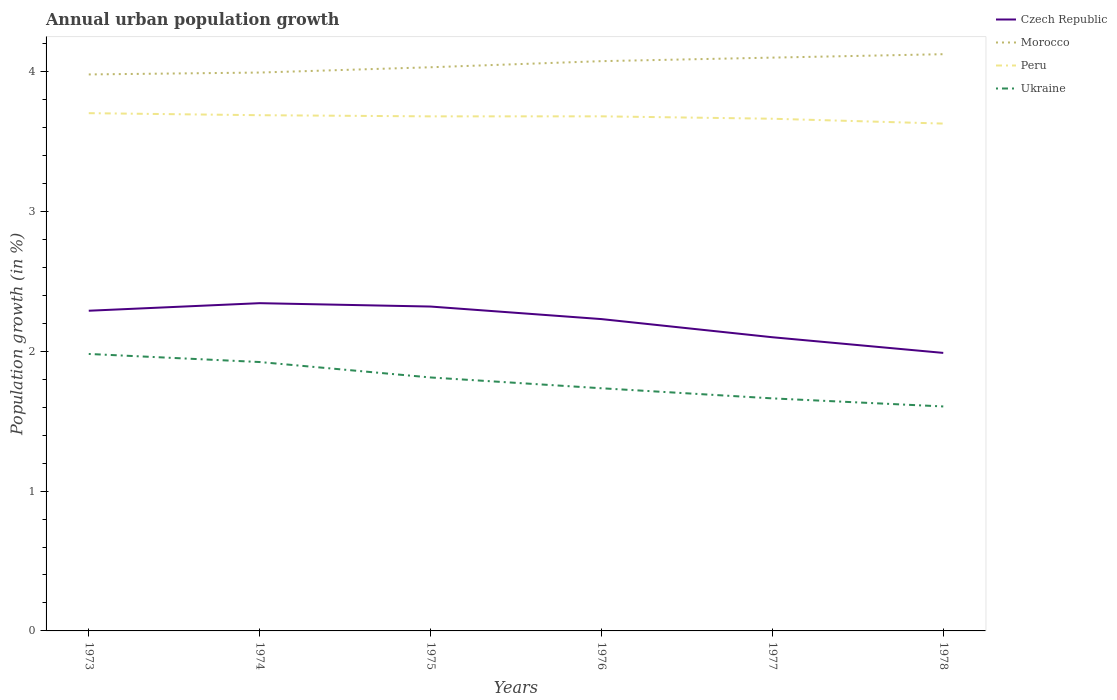How many different coloured lines are there?
Your answer should be very brief. 4. Is the number of lines equal to the number of legend labels?
Provide a short and direct response. Yes. Across all years, what is the maximum percentage of urban population growth in Morocco?
Provide a succinct answer. 3.98. In which year was the percentage of urban population growth in Ukraine maximum?
Offer a terse response. 1978. What is the total percentage of urban population growth in Morocco in the graph?
Provide a short and direct response. -0.04. What is the difference between the highest and the second highest percentage of urban population growth in Czech Republic?
Your response must be concise. 0.36. What is the difference between the highest and the lowest percentage of urban population growth in Peru?
Provide a short and direct response. 4. How many lines are there?
Offer a very short reply. 4. Are the values on the major ticks of Y-axis written in scientific E-notation?
Your response must be concise. No. Does the graph contain any zero values?
Provide a short and direct response. No. Does the graph contain grids?
Your answer should be compact. No. Where does the legend appear in the graph?
Make the answer very short. Top right. How are the legend labels stacked?
Your answer should be compact. Vertical. What is the title of the graph?
Offer a terse response. Annual urban population growth. What is the label or title of the X-axis?
Provide a short and direct response. Years. What is the label or title of the Y-axis?
Provide a short and direct response. Population growth (in %). What is the Population growth (in %) of Czech Republic in 1973?
Keep it short and to the point. 2.29. What is the Population growth (in %) in Morocco in 1973?
Offer a terse response. 3.98. What is the Population growth (in %) in Peru in 1973?
Give a very brief answer. 3.7. What is the Population growth (in %) in Ukraine in 1973?
Your answer should be compact. 1.98. What is the Population growth (in %) in Czech Republic in 1974?
Give a very brief answer. 2.34. What is the Population growth (in %) in Morocco in 1974?
Make the answer very short. 3.99. What is the Population growth (in %) in Peru in 1974?
Your answer should be compact. 3.69. What is the Population growth (in %) in Ukraine in 1974?
Your answer should be compact. 1.92. What is the Population growth (in %) in Czech Republic in 1975?
Provide a short and direct response. 2.32. What is the Population growth (in %) of Morocco in 1975?
Offer a very short reply. 4.03. What is the Population growth (in %) of Peru in 1975?
Your response must be concise. 3.68. What is the Population growth (in %) in Ukraine in 1975?
Provide a short and direct response. 1.81. What is the Population growth (in %) of Czech Republic in 1976?
Make the answer very short. 2.23. What is the Population growth (in %) in Morocco in 1976?
Provide a short and direct response. 4.07. What is the Population growth (in %) of Peru in 1976?
Offer a very short reply. 3.68. What is the Population growth (in %) in Ukraine in 1976?
Your answer should be compact. 1.73. What is the Population growth (in %) in Czech Republic in 1977?
Your answer should be compact. 2.1. What is the Population growth (in %) in Morocco in 1977?
Keep it short and to the point. 4.1. What is the Population growth (in %) of Peru in 1977?
Make the answer very short. 3.66. What is the Population growth (in %) in Ukraine in 1977?
Make the answer very short. 1.66. What is the Population growth (in %) of Czech Republic in 1978?
Provide a succinct answer. 1.99. What is the Population growth (in %) of Morocco in 1978?
Your answer should be very brief. 4.12. What is the Population growth (in %) in Peru in 1978?
Ensure brevity in your answer.  3.63. What is the Population growth (in %) in Ukraine in 1978?
Provide a short and direct response. 1.6. Across all years, what is the maximum Population growth (in %) of Czech Republic?
Offer a terse response. 2.34. Across all years, what is the maximum Population growth (in %) in Morocco?
Provide a short and direct response. 4.12. Across all years, what is the maximum Population growth (in %) of Peru?
Make the answer very short. 3.7. Across all years, what is the maximum Population growth (in %) in Ukraine?
Offer a very short reply. 1.98. Across all years, what is the minimum Population growth (in %) in Czech Republic?
Make the answer very short. 1.99. Across all years, what is the minimum Population growth (in %) in Morocco?
Your answer should be compact. 3.98. Across all years, what is the minimum Population growth (in %) of Peru?
Your answer should be very brief. 3.63. Across all years, what is the minimum Population growth (in %) in Ukraine?
Provide a short and direct response. 1.6. What is the total Population growth (in %) in Czech Republic in the graph?
Provide a short and direct response. 13.27. What is the total Population growth (in %) of Morocco in the graph?
Make the answer very short. 24.3. What is the total Population growth (in %) in Peru in the graph?
Offer a terse response. 22.04. What is the total Population growth (in %) of Ukraine in the graph?
Keep it short and to the point. 10.72. What is the difference between the Population growth (in %) in Czech Republic in 1973 and that in 1974?
Ensure brevity in your answer.  -0.05. What is the difference between the Population growth (in %) in Morocco in 1973 and that in 1974?
Ensure brevity in your answer.  -0.01. What is the difference between the Population growth (in %) of Peru in 1973 and that in 1974?
Give a very brief answer. 0.01. What is the difference between the Population growth (in %) in Ukraine in 1973 and that in 1974?
Make the answer very short. 0.06. What is the difference between the Population growth (in %) in Czech Republic in 1973 and that in 1975?
Ensure brevity in your answer.  -0.03. What is the difference between the Population growth (in %) in Morocco in 1973 and that in 1975?
Keep it short and to the point. -0.05. What is the difference between the Population growth (in %) of Peru in 1973 and that in 1975?
Make the answer very short. 0.02. What is the difference between the Population growth (in %) of Ukraine in 1973 and that in 1975?
Your answer should be compact. 0.17. What is the difference between the Population growth (in %) of Czech Republic in 1973 and that in 1976?
Provide a succinct answer. 0.06. What is the difference between the Population growth (in %) of Morocco in 1973 and that in 1976?
Give a very brief answer. -0.09. What is the difference between the Population growth (in %) in Peru in 1973 and that in 1976?
Provide a succinct answer. 0.02. What is the difference between the Population growth (in %) of Ukraine in 1973 and that in 1976?
Give a very brief answer. 0.25. What is the difference between the Population growth (in %) of Czech Republic in 1973 and that in 1977?
Your answer should be compact. 0.19. What is the difference between the Population growth (in %) of Morocco in 1973 and that in 1977?
Offer a terse response. -0.12. What is the difference between the Population growth (in %) of Peru in 1973 and that in 1977?
Make the answer very short. 0.04. What is the difference between the Population growth (in %) in Ukraine in 1973 and that in 1977?
Provide a short and direct response. 0.32. What is the difference between the Population growth (in %) in Czech Republic in 1973 and that in 1978?
Keep it short and to the point. 0.3. What is the difference between the Population growth (in %) in Morocco in 1973 and that in 1978?
Provide a short and direct response. -0.14. What is the difference between the Population growth (in %) of Peru in 1973 and that in 1978?
Provide a short and direct response. 0.07. What is the difference between the Population growth (in %) of Ukraine in 1973 and that in 1978?
Your response must be concise. 0.38. What is the difference between the Population growth (in %) of Czech Republic in 1974 and that in 1975?
Your answer should be compact. 0.02. What is the difference between the Population growth (in %) of Morocco in 1974 and that in 1975?
Your answer should be very brief. -0.04. What is the difference between the Population growth (in %) of Peru in 1974 and that in 1975?
Your answer should be very brief. 0.01. What is the difference between the Population growth (in %) in Ukraine in 1974 and that in 1975?
Provide a succinct answer. 0.11. What is the difference between the Population growth (in %) in Czech Republic in 1974 and that in 1976?
Provide a short and direct response. 0.11. What is the difference between the Population growth (in %) of Morocco in 1974 and that in 1976?
Your response must be concise. -0.08. What is the difference between the Population growth (in %) in Peru in 1974 and that in 1976?
Make the answer very short. 0.01. What is the difference between the Population growth (in %) of Ukraine in 1974 and that in 1976?
Your answer should be compact. 0.19. What is the difference between the Population growth (in %) in Czech Republic in 1974 and that in 1977?
Give a very brief answer. 0.24. What is the difference between the Population growth (in %) of Morocco in 1974 and that in 1977?
Offer a terse response. -0.11. What is the difference between the Population growth (in %) in Peru in 1974 and that in 1977?
Provide a succinct answer. 0.03. What is the difference between the Population growth (in %) of Ukraine in 1974 and that in 1977?
Offer a very short reply. 0.26. What is the difference between the Population growth (in %) in Czech Republic in 1974 and that in 1978?
Keep it short and to the point. 0.36. What is the difference between the Population growth (in %) in Morocco in 1974 and that in 1978?
Provide a short and direct response. -0.13. What is the difference between the Population growth (in %) of Peru in 1974 and that in 1978?
Provide a short and direct response. 0.06. What is the difference between the Population growth (in %) of Ukraine in 1974 and that in 1978?
Ensure brevity in your answer.  0.32. What is the difference between the Population growth (in %) in Czech Republic in 1975 and that in 1976?
Your answer should be compact. 0.09. What is the difference between the Population growth (in %) in Morocco in 1975 and that in 1976?
Provide a short and direct response. -0.04. What is the difference between the Population growth (in %) in Peru in 1975 and that in 1976?
Keep it short and to the point. -0. What is the difference between the Population growth (in %) of Ukraine in 1975 and that in 1976?
Provide a short and direct response. 0.08. What is the difference between the Population growth (in %) of Czech Republic in 1975 and that in 1977?
Offer a very short reply. 0.22. What is the difference between the Population growth (in %) of Morocco in 1975 and that in 1977?
Offer a very short reply. -0.07. What is the difference between the Population growth (in %) in Peru in 1975 and that in 1977?
Your answer should be very brief. 0.02. What is the difference between the Population growth (in %) in Ukraine in 1975 and that in 1977?
Keep it short and to the point. 0.15. What is the difference between the Population growth (in %) of Czech Republic in 1975 and that in 1978?
Provide a succinct answer. 0.33. What is the difference between the Population growth (in %) in Morocco in 1975 and that in 1978?
Offer a very short reply. -0.09. What is the difference between the Population growth (in %) in Peru in 1975 and that in 1978?
Your answer should be compact. 0.05. What is the difference between the Population growth (in %) in Ukraine in 1975 and that in 1978?
Your answer should be compact. 0.21. What is the difference between the Population growth (in %) of Czech Republic in 1976 and that in 1977?
Your answer should be very brief. 0.13. What is the difference between the Population growth (in %) in Morocco in 1976 and that in 1977?
Give a very brief answer. -0.03. What is the difference between the Population growth (in %) in Peru in 1976 and that in 1977?
Offer a very short reply. 0.02. What is the difference between the Population growth (in %) of Ukraine in 1976 and that in 1977?
Your answer should be compact. 0.07. What is the difference between the Population growth (in %) of Czech Republic in 1976 and that in 1978?
Make the answer very short. 0.24. What is the difference between the Population growth (in %) of Morocco in 1976 and that in 1978?
Offer a terse response. -0.05. What is the difference between the Population growth (in %) in Peru in 1976 and that in 1978?
Provide a short and direct response. 0.05. What is the difference between the Population growth (in %) of Ukraine in 1976 and that in 1978?
Make the answer very short. 0.13. What is the difference between the Population growth (in %) in Czech Republic in 1977 and that in 1978?
Offer a terse response. 0.11. What is the difference between the Population growth (in %) in Morocco in 1977 and that in 1978?
Your answer should be compact. -0.02. What is the difference between the Population growth (in %) in Peru in 1977 and that in 1978?
Provide a succinct answer. 0.03. What is the difference between the Population growth (in %) in Ukraine in 1977 and that in 1978?
Ensure brevity in your answer.  0.06. What is the difference between the Population growth (in %) of Czech Republic in 1973 and the Population growth (in %) of Morocco in 1974?
Your answer should be compact. -1.7. What is the difference between the Population growth (in %) of Czech Republic in 1973 and the Population growth (in %) of Peru in 1974?
Give a very brief answer. -1.4. What is the difference between the Population growth (in %) in Czech Republic in 1973 and the Population growth (in %) in Ukraine in 1974?
Your response must be concise. 0.37. What is the difference between the Population growth (in %) of Morocco in 1973 and the Population growth (in %) of Peru in 1974?
Your response must be concise. 0.29. What is the difference between the Population growth (in %) of Morocco in 1973 and the Population growth (in %) of Ukraine in 1974?
Your answer should be compact. 2.06. What is the difference between the Population growth (in %) in Peru in 1973 and the Population growth (in %) in Ukraine in 1974?
Your response must be concise. 1.78. What is the difference between the Population growth (in %) of Czech Republic in 1973 and the Population growth (in %) of Morocco in 1975?
Offer a very short reply. -1.74. What is the difference between the Population growth (in %) in Czech Republic in 1973 and the Population growth (in %) in Peru in 1975?
Provide a succinct answer. -1.39. What is the difference between the Population growth (in %) of Czech Republic in 1973 and the Population growth (in %) of Ukraine in 1975?
Keep it short and to the point. 0.48. What is the difference between the Population growth (in %) in Morocco in 1973 and the Population growth (in %) in Peru in 1975?
Provide a short and direct response. 0.3. What is the difference between the Population growth (in %) of Morocco in 1973 and the Population growth (in %) of Ukraine in 1975?
Offer a terse response. 2.17. What is the difference between the Population growth (in %) in Peru in 1973 and the Population growth (in %) in Ukraine in 1975?
Offer a terse response. 1.89. What is the difference between the Population growth (in %) of Czech Republic in 1973 and the Population growth (in %) of Morocco in 1976?
Make the answer very short. -1.78. What is the difference between the Population growth (in %) in Czech Republic in 1973 and the Population growth (in %) in Peru in 1976?
Keep it short and to the point. -1.39. What is the difference between the Population growth (in %) of Czech Republic in 1973 and the Population growth (in %) of Ukraine in 1976?
Offer a terse response. 0.55. What is the difference between the Population growth (in %) of Morocco in 1973 and the Population growth (in %) of Peru in 1976?
Offer a terse response. 0.3. What is the difference between the Population growth (in %) of Morocco in 1973 and the Population growth (in %) of Ukraine in 1976?
Offer a very short reply. 2.24. What is the difference between the Population growth (in %) in Peru in 1973 and the Population growth (in %) in Ukraine in 1976?
Provide a succinct answer. 1.97. What is the difference between the Population growth (in %) in Czech Republic in 1973 and the Population growth (in %) in Morocco in 1977?
Offer a very short reply. -1.81. What is the difference between the Population growth (in %) in Czech Republic in 1973 and the Population growth (in %) in Peru in 1977?
Provide a short and direct response. -1.37. What is the difference between the Population growth (in %) in Czech Republic in 1973 and the Population growth (in %) in Ukraine in 1977?
Ensure brevity in your answer.  0.63. What is the difference between the Population growth (in %) in Morocco in 1973 and the Population growth (in %) in Peru in 1977?
Provide a short and direct response. 0.32. What is the difference between the Population growth (in %) in Morocco in 1973 and the Population growth (in %) in Ukraine in 1977?
Ensure brevity in your answer.  2.32. What is the difference between the Population growth (in %) of Peru in 1973 and the Population growth (in %) of Ukraine in 1977?
Provide a short and direct response. 2.04. What is the difference between the Population growth (in %) in Czech Republic in 1973 and the Population growth (in %) in Morocco in 1978?
Ensure brevity in your answer.  -1.83. What is the difference between the Population growth (in %) of Czech Republic in 1973 and the Population growth (in %) of Peru in 1978?
Provide a short and direct response. -1.34. What is the difference between the Population growth (in %) in Czech Republic in 1973 and the Population growth (in %) in Ukraine in 1978?
Keep it short and to the point. 0.68. What is the difference between the Population growth (in %) of Morocco in 1973 and the Population growth (in %) of Peru in 1978?
Offer a very short reply. 0.35. What is the difference between the Population growth (in %) in Morocco in 1973 and the Population growth (in %) in Ukraine in 1978?
Give a very brief answer. 2.37. What is the difference between the Population growth (in %) of Peru in 1973 and the Population growth (in %) of Ukraine in 1978?
Give a very brief answer. 2.1. What is the difference between the Population growth (in %) in Czech Republic in 1974 and the Population growth (in %) in Morocco in 1975?
Offer a very short reply. -1.69. What is the difference between the Population growth (in %) of Czech Republic in 1974 and the Population growth (in %) of Peru in 1975?
Offer a terse response. -1.34. What is the difference between the Population growth (in %) in Czech Republic in 1974 and the Population growth (in %) in Ukraine in 1975?
Give a very brief answer. 0.53. What is the difference between the Population growth (in %) of Morocco in 1974 and the Population growth (in %) of Peru in 1975?
Your answer should be very brief. 0.31. What is the difference between the Population growth (in %) of Morocco in 1974 and the Population growth (in %) of Ukraine in 1975?
Provide a succinct answer. 2.18. What is the difference between the Population growth (in %) in Peru in 1974 and the Population growth (in %) in Ukraine in 1975?
Provide a succinct answer. 1.88. What is the difference between the Population growth (in %) in Czech Republic in 1974 and the Population growth (in %) in Morocco in 1976?
Your answer should be compact. -1.73. What is the difference between the Population growth (in %) of Czech Republic in 1974 and the Population growth (in %) of Peru in 1976?
Your answer should be very brief. -1.34. What is the difference between the Population growth (in %) in Czech Republic in 1974 and the Population growth (in %) in Ukraine in 1976?
Offer a terse response. 0.61. What is the difference between the Population growth (in %) of Morocco in 1974 and the Population growth (in %) of Peru in 1976?
Offer a very short reply. 0.31. What is the difference between the Population growth (in %) of Morocco in 1974 and the Population growth (in %) of Ukraine in 1976?
Your answer should be compact. 2.26. What is the difference between the Population growth (in %) in Peru in 1974 and the Population growth (in %) in Ukraine in 1976?
Offer a terse response. 1.95. What is the difference between the Population growth (in %) of Czech Republic in 1974 and the Population growth (in %) of Morocco in 1977?
Ensure brevity in your answer.  -1.76. What is the difference between the Population growth (in %) of Czech Republic in 1974 and the Population growth (in %) of Peru in 1977?
Give a very brief answer. -1.32. What is the difference between the Population growth (in %) of Czech Republic in 1974 and the Population growth (in %) of Ukraine in 1977?
Offer a terse response. 0.68. What is the difference between the Population growth (in %) in Morocco in 1974 and the Population growth (in %) in Peru in 1977?
Provide a short and direct response. 0.33. What is the difference between the Population growth (in %) in Morocco in 1974 and the Population growth (in %) in Ukraine in 1977?
Your answer should be very brief. 2.33. What is the difference between the Population growth (in %) of Peru in 1974 and the Population growth (in %) of Ukraine in 1977?
Make the answer very short. 2.02. What is the difference between the Population growth (in %) of Czech Republic in 1974 and the Population growth (in %) of Morocco in 1978?
Give a very brief answer. -1.78. What is the difference between the Population growth (in %) of Czech Republic in 1974 and the Population growth (in %) of Peru in 1978?
Provide a succinct answer. -1.28. What is the difference between the Population growth (in %) in Czech Republic in 1974 and the Population growth (in %) in Ukraine in 1978?
Make the answer very short. 0.74. What is the difference between the Population growth (in %) of Morocco in 1974 and the Population growth (in %) of Peru in 1978?
Your answer should be compact. 0.36. What is the difference between the Population growth (in %) of Morocco in 1974 and the Population growth (in %) of Ukraine in 1978?
Offer a terse response. 2.39. What is the difference between the Population growth (in %) in Peru in 1974 and the Population growth (in %) in Ukraine in 1978?
Provide a short and direct response. 2.08. What is the difference between the Population growth (in %) in Czech Republic in 1975 and the Population growth (in %) in Morocco in 1976?
Your response must be concise. -1.75. What is the difference between the Population growth (in %) of Czech Republic in 1975 and the Population growth (in %) of Peru in 1976?
Keep it short and to the point. -1.36. What is the difference between the Population growth (in %) of Czech Republic in 1975 and the Population growth (in %) of Ukraine in 1976?
Ensure brevity in your answer.  0.58. What is the difference between the Population growth (in %) of Morocco in 1975 and the Population growth (in %) of Peru in 1976?
Give a very brief answer. 0.35. What is the difference between the Population growth (in %) in Morocco in 1975 and the Population growth (in %) in Ukraine in 1976?
Your answer should be very brief. 2.3. What is the difference between the Population growth (in %) in Peru in 1975 and the Population growth (in %) in Ukraine in 1976?
Offer a very short reply. 1.94. What is the difference between the Population growth (in %) of Czech Republic in 1975 and the Population growth (in %) of Morocco in 1977?
Give a very brief answer. -1.78. What is the difference between the Population growth (in %) of Czech Republic in 1975 and the Population growth (in %) of Peru in 1977?
Your answer should be very brief. -1.34. What is the difference between the Population growth (in %) of Czech Republic in 1975 and the Population growth (in %) of Ukraine in 1977?
Your answer should be compact. 0.66. What is the difference between the Population growth (in %) in Morocco in 1975 and the Population growth (in %) in Peru in 1977?
Keep it short and to the point. 0.37. What is the difference between the Population growth (in %) of Morocco in 1975 and the Population growth (in %) of Ukraine in 1977?
Keep it short and to the point. 2.37. What is the difference between the Population growth (in %) of Peru in 1975 and the Population growth (in %) of Ukraine in 1977?
Your answer should be very brief. 2.02. What is the difference between the Population growth (in %) of Czech Republic in 1975 and the Population growth (in %) of Morocco in 1978?
Offer a very short reply. -1.8. What is the difference between the Population growth (in %) in Czech Republic in 1975 and the Population growth (in %) in Peru in 1978?
Your answer should be very brief. -1.31. What is the difference between the Population growth (in %) of Czech Republic in 1975 and the Population growth (in %) of Ukraine in 1978?
Your answer should be compact. 0.71. What is the difference between the Population growth (in %) in Morocco in 1975 and the Population growth (in %) in Peru in 1978?
Your answer should be very brief. 0.4. What is the difference between the Population growth (in %) in Morocco in 1975 and the Population growth (in %) in Ukraine in 1978?
Provide a succinct answer. 2.43. What is the difference between the Population growth (in %) of Peru in 1975 and the Population growth (in %) of Ukraine in 1978?
Give a very brief answer. 2.07. What is the difference between the Population growth (in %) of Czech Republic in 1976 and the Population growth (in %) of Morocco in 1977?
Your response must be concise. -1.87. What is the difference between the Population growth (in %) in Czech Republic in 1976 and the Population growth (in %) in Peru in 1977?
Keep it short and to the point. -1.43. What is the difference between the Population growth (in %) of Czech Republic in 1976 and the Population growth (in %) of Ukraine in 1977?
Offer a terse response. 0.57. What is the difference between the Population growth (in %) of Morocco in 1976 and the Population growth (in %) of Peru in 1977?
Ensure brevity in your answer.  0.41. What is the difference between the Population growth (in %) in Morocco in 1976 and the Population growth (in %) in Ukraine in 1977?
Make the answer very short. 2.41. What is the difference between the Population growth (in %) of Peru in 1976 and the Population growth (in %) of Ukraine in 1977?
Provide a succinct answer. 2.02. What is the difference between the Population growth (in %) of Czech Republic in 1976 and the Population growth (in %) of Morocco in 1978?
Ensure brevity in your answer.  -1.89. What is the difference between the Population growth (in %) of Czech Republic in 1976 and the Population growth (in %) of Peru in 1978?
Keep it short and to the point. -1.4. What is the difference between the Population growth (in %) in Czech Republic in 1976 and the Population growth (in %) in Ukraine in 1978?
Your answer should be compact. 0.62. What is the difference between the Population growth (in %) of Morocco in 1976 and the Population growth (in %) of Peru in 1978?
Offer a very short reply. 0.45. What is the difference between the Population growth (in %) of Morocco in 1976 and the Population growth (in %) of Ukraine in 1978?
Keep it short and to the point. 2.47. What is the difference between the Population growth (in %) in Peru in 1976 and the Population growth (in %) in Ukraine in 1978?
Keep it short and to the point. 2.07. What is the difference between the Population growth (in %) of Czech Republic in 1977 and the Population growth (in %) of Morocco in 1978?
Your response must be concise. -2.02. What is the difference between the Population growth (in %) in Czech Republic in 1977 and the Population growth (in %) in Peru in 1978?
Ensure brevity in your answer.  -1.53. What is the difference between the Population growth (in %) in Czech Republic in 1977 and the Population growth (in %) in Ukraine in 1978?
Keep it short and to the point. 0.49. What is the difference between the Population growth (in %) in Morocco in 1977 and the Population growth (in %) in Peru in 1978?
Your response must be concise. 0.47. What is the difference between the Population growth (in %) of Morocco in 1977 and the Population growth (in %) of Ukraine in 1978?
Keep it short and to the point. 2.49. What is the difference between the Population growth (in %) in Peru in 1977 and the Population growth (in %) in Ukraine in 1978?
Give a very brief answer. 2.06. What is the average Population growth (in %) in Czech Republic per year?
Ensure brevity in your answer.  2.21. What is the average Population growth (in %) of Morocco per year?
Your response must be concise. 4.05. What is the average Population growth (in %) of Peru per year?
Ensure brevity in your answer.  3.67. What is the average Population growth (in %) in Ukraine per year?
Your answer should be very brief. 1.79. In the year 1973, what is the difference between the Population growth (in %) in Czech Republic and Population growth (in %) in Morocco?
Your answer should be very brief. -1.69. In the year 1973, what is the difference between the Population growth (in %) in Czech Republic and Population growth (in %) in Peru?
Your answer should be compact. -1.41. In the year 1973, what is the difference between the Population growth (in %) in Czech Republic and Population growth (in %) in Ukraine?
Ensure brevity in your answer.  0.31. In the year 1973, what is the difference between the Population growth (in %) of Morocco and Population growth (in %) of Peru?
Offer a terse response. 0.28. In the year 1973, what is the difference between the Population growth (in %) of Morocco and Population growth (in %) of Ukraine?
Ensure brevity in your answer.  2. In the year 1973, what is the difference between the Population growth (in %) of Peru and Population growth (in %) of Ukraine?
Offer a very short reply. 1.72. In the year 1974, what is the difference between the Population growth (in %) in Czech Republic and Population growth (in %) in Morocco?
Provide a succinct answer. -1.65. In the year 1974, what is the difference between the Population growth (in %) of Czech Republic and Population growth (in %) of Peru?
Make the answer very short. -1.34. In the year 1974, what is the difference between the Population growth (in %) in Czech Republic and Population growth (in %) in Ukraine?
Ensure brevity in your answer.  0.42. In the year 1974, what is the difference between the Population growth (in %) in Morocco and Population growth (in %) in Peru?
Make the answer very short. 0.3. In the year 1974, what is the difference between the Population growth (in %) of Morocco and Population growth (in %) of Ukraine?
Your response must be concise. 2.07. In the year 1974, what is the difference between the Population growth (in %) of Peru and Population growth (in %) of Ukraine?
Give a very brief answer. 1.76. In the year 1975, what is the difference between the Population growth (in %) in Czech Republic and Population growth (in %) in Morocco?
Your answer should be compact. -1.71. In the year 1975, what is the difference between the Population growth (in %) in Czech Republic and Population growth (in %) in Peru?
Your response must be concise. -1.36. In the year 1975, what is the difference between the Population growth (in %) in Czech Republic and Population growth (in %) in Ukraine?
Offer a very short reply. 0.51. In the year 1975, what is the difference between the Population growth (in %) of Morocco and Population growth (in %) of Peru?
Give a very brief answer. 0.35. In the year 1975, what is the difference between the Population growth (in %) in Morocco and Population growth (in %) in Ukraine?
Ensure brevity in your answer.  2.22. In the year 1975, what is the difference between the Population growth (in %) in Peru and Population growth (in %) in Ukraine?
Offer a very short reply. 1.87. In the year 1976, what is the difference between the Population growth (in %) in Czech Republic and Population growth (in %) in Morocco?
Offer a terse response. -1.84. In the year 1976, what is the difference between the Population growth (in %) of Czech Republic and Population growth (in %) of Peru?
Ensure brevity in your answer.  -1.45. In the year 1976, what is the difference between the Population growth (in %) of Czech Republic and Population growth (in %) of Ukraine?
Provide a short and direct response. 0.49. In the year 1976, what is the difference between the Population growth (in %) in Morocco and Population growth (in %) in Peru?
Provide a succinct answer. 0.39. In the year 1976, what is the difference between the Population growth (in %) of Morocco and Population growth (in %) of Ukraine?
Offer a terse response. 2.34. In the year 1976, what is the difference between the Population growth (in %) in Peru and Population growth (in %) in Ukraine?
Offer a very short reply. 1.94. In the year 1977, what is the difference between the Population growth (in %) in Czech Republic and Population growth (in %) in Morocco?
Make the answer very short. -2. In the year 1977, what is the difference between the Population growth (in %) in Czech Republic and Population growth (in %) in Peru?
Your answer should be very brief. -1.56. In the year 1977, what is the difference between the Population growth (in %) of Czech Republic and Population growth (in %) of Ukraine?
Keep it short and to the point. 0.44. In the year 1977, what is the difference between the Population growth (in %) in Morocco and Population growth (in %) in Peru?
Your answer should be very brief. 0.44. In the year 1977, what is the difference between the Population growth (in %) of Morocco and Population growth (in %) of Ukraine?
Your answer should be very brief. 2.44. In the year 1977, what is the difference between the Population growth (in %) of Peru and Population growth (in %) of Ukraine?
Provide a succinct answer. 2. In the year 1978, what is the difference between the Population growth (in %) in Czech Republic and Population growth (in %) in Morocco?
Offer a terse response. -2.14. In the year 1978, what is the difference between the Population growth (in %) of Czech Republic and Population growth (in %) of Peru?
Provide a short and direct response. -1.64. In the year 1978, what is the difference between the Population growth (in %) of Czech Republic and Population growth (in %) of Ukraine?
Provide a short and direct response. 0.38. In the year 1978, what is the difference between the Population growth (in %) of Morocco and Population growth (in %) of Peru?
Provide a succinct answer. 0.5. In the year 1978, what is the difference between the Population growth (in %) of Morocco and Population growth (in %) of Ukraine?
Your answer should be compact. 2.52. In the year 1978, what is the difference between the Population growth (in %) of Peru and Population growth (in %) of Ukraine?
Your answer should be very brief. 2.02. What is the ratio of the Population growth (in %) in Peru in 1973 to that in 1974?
Provide a short and direct response. 1. What is the ratio of the Population growth (in %) of Ukraine in 1973 to that in 1974?
Your response must be concise. 1.03. What is the ratio of the Population growth (in %) in Czech Republic in 1973 to that in 1975?
Offer a terse response. 0.99. What is the ratio of the Population growth (in %) in Morocco in 1973 to that in 1975?
Provide a short and direct response. 0.99. What is the ratio of the Population growth (in %) in Ukraine in 1973 to that in 1975?
Offer a terse response. 1.09. What is the ratio of the Population growth (in %) of Czech Republic in 1973 to that in 1976?
Your response must be concise. 1.03. What is the ratio of the Population growth (in %) in Morocco in 1973 to that in 1976?
Offer a terse response. 0.98. What is the ratio of the Population growth (in %) of Peru in 1973 to that in 1976?
Your answer should be very brief. 1.01. What is the ratio of the Population growth (in %) of Ukraine in 1973 to that in 1976?
Your response must be concise. 1.14. What is the ratio of the Population growth (in %) in Czech Republic in 1973 to that in 1977?
Keep it short and to the point. 1.09. What is the ratio of the Population growth (in %) of Morocco in 1973 to that in 1977?
Make the answer very short. 0.97. What is the ratio of the Population growth (in %) of Peru in 1973 to that in 1977?
Provide a short and direct response. 1.01. What is the ratio of the Population growth (in %) in Ukraine in 1973 to that in 1977?
Give a very brief answer. 1.19. What is the ratio of the Population growth (in %) of Czech Republic in 1973 to that in 1978?
Your answer should be very brief. 1.15. What is the ratio of the Population growth (in %) of Morocco in 1973 to that in 1978?
Offer a terse response. 0.96. What is the ratio of the Population growth (in %) in Peru in 1973 to that in 1978?
Ensure brevity in your answer.  1.02. What is the ratio of the Population growth (in %) in Ukraine in 1973 to that in 1978?
Your response must be concise. 1.23. What is the ratio of the Population growth (in %) in Czech Republic in 1974 to that in 1975?
Offer a very short reply. 1.01. What is the ratio of the Population growth (in %) in Morocco in 1974 to that in 1975?
Make the answer very short. 0.99. What is the ratio of the Population growth (in %) of Ukraine in 1974 to that in 1975?
Provide a short and direct response. 1.06. What is the ratio of the Population growth (in %) in Czech Republic in 1974 to that in 1976?
Your answer should be compact. 1.05. What is the ratio of the Population growth (in %) in Morocco in 1974 to that in 1976?
Offer a terse response. 0.98. What is the ratio of the Population growth (in %) in Peru in 1974 to that in 1976?
Provide a short and direct response. 1. What is the ratio of the Population growth (in %) of Ukraine in 1974 to that in 1976?
Your response must be concise. 1.11. What is the ratio of the Population growth (in %) in Czech Republic in 1974 to that in 1977?
Make the answer very short. 1.12. What is the ratio of the Population growth (in %) in Morocco in 1974 to that in 1977?
Offer a terse response. 0.97. What is the ratio of the Population growth (in %) in Peru in 1974 to that in 1977?
Ensure brevity in your answer.  1.01. What is the ratio of the Population growth (in %) in Ukraine in 1974 to that in 1977?
Provide a short and direct response. 1.16. What is the ratio of the Population growth (in %) of Czech Republic in 1974 to that in 1978?
Offer a very short reply. 1.18. What is the ratio of the Population growth (in %) in Morocco in 1974 to that in 1978?
Provide a succinct answer. 0.97. What is the ratio of the Population growth (in %) of Peru in 1974 to that in 1978?
Your answer should be compact. 1.02. What is the ratio of the Population growth (in %) in Ukraine in 1974 to that in 1978?
Keep it short and to the point. 1.2. What is the ratio of the Population growth (in %) of Czech Republic in 1975 to that in 1976?
Give a very brief answer. 1.04. What is the ratio of the Population growth (in %) in Morocco in 1975 to that in 1976?
Your answer should be compact. 0.99. What is the ratio of the Population growth (in %) in Peru in 1975 to that in 1976?
Your answer should be very brief. 1. What is the ratio of the Population growth (in %) of Ukraine in 1975 to that in 1976?
Your answer should be compact. 1.04. What is the ratio of the Population growth (in %) in Czech Republic in 1975 to that in 1977?
Provide a succinct answer. 1.1. What is the ratio of the Population growth (in %) in Morocco in 1975 to that in 1977?
Make the answer very short. 0.98. What is the ratio of the Population growth (in %) in Peru in 1975 to that in 1977?
Your answer should be very brief. 1. What is the ratio of the Population growth (in %) of Ukraine in 1975 to that in 1977?
Keep it short and to the point. 1.09. What is the ratio of the Population growth (in %) of Czech Republic in 1975 to that in 1978?
Provide a succinct answer. 1.17. What is the ratio of the Population growth (in %) in Morocco in 1975 to that in 1978?
Provide a succinct answer. 0.98. What is the ratio of the Population growth (in %) in Peru in 1975 to that in 1978?
Offer a terse response. 1.01. What is the ratio of the Population growth (in %) in Ukraine in 1975 to that in 1978?
Provide a short and direct response. 1.13. What is the ratio of the Population growth (in %) of Czech Republic in 1976 to that in 1977?
Your answer should be very brief. 1.06. What is the ratio of the Population growth (in %) in Peru in 1976 to that in 1977?
Keep it short and to the point. 1. What is the ratio of the Population growth (in %) in Ukraine in 1976 to that in 1977?
Offer a terse response. 1.04. What is the ratio of the Population growth (in %) in Czech Republic in 1976 to that in 1978?
Give a very brief answer. 1.12. What is the ratio of the Population growth (in %) in Morocco in 1976 to that in 1978?
Keep it short and to the point. 0.99. What is the ratio of the Population growth (in %) of Peru in 1976 to that in 1978?
Your answer should be very brief. 1.01. What is the ratio of the Population growth (in %) in Ukraine in 1976 to that in 1978?
Offer a terse response. 1.08. What is the ratio of the Population growth (in %) of Czech Republic in 1977 to that in 1978?
Ensure brevity in your answer.  1.06. What is the ratio of the Population growth (in %) of Morocco in 1977 to that in 1978?
Provide a short and direct response. 0.99. What is the ratio of the Population growth (in %) in Peru in 1977 to that in 1978?
Provide a succinct answer. 1.01. What is the ratio of the Population growth (in %) in Ukraine in 1977 to that in 1978?
Ensure brevity in your answer.  1.04. What is the difference between the highest and the second highest Population growth (in %) in Czech Republic?
Make the answer very short. 0.02. What is the difference between the highest and the second highest Population growth (in %) of Morocco?
Your answer should be compact. 0.02. What is the difference between the highest and the second highest Population growth (in %) in Peru?
Your answer should be compact. 0.01. What is the difference between the highest and the second highest Population growth (in %) in Ukraine?
Keep it short and to the point. 0.06. What is the difference between the highest and the lowest Population growth (in %) in Czech Republic?
Offer a terse response. 0.36. What is the difference between the highest and the lowest Population growth (in %) of Morocco?
Your answer should be very brief. 0.14. What is the difference between the highest and the lowest Population growth (in %) of Peru?
Provide a succinct answer. 0.07. What is the difference between the highest and the lowest Population growth (in %) of Ukraine?
Keep it short and to the point. 0.38. 